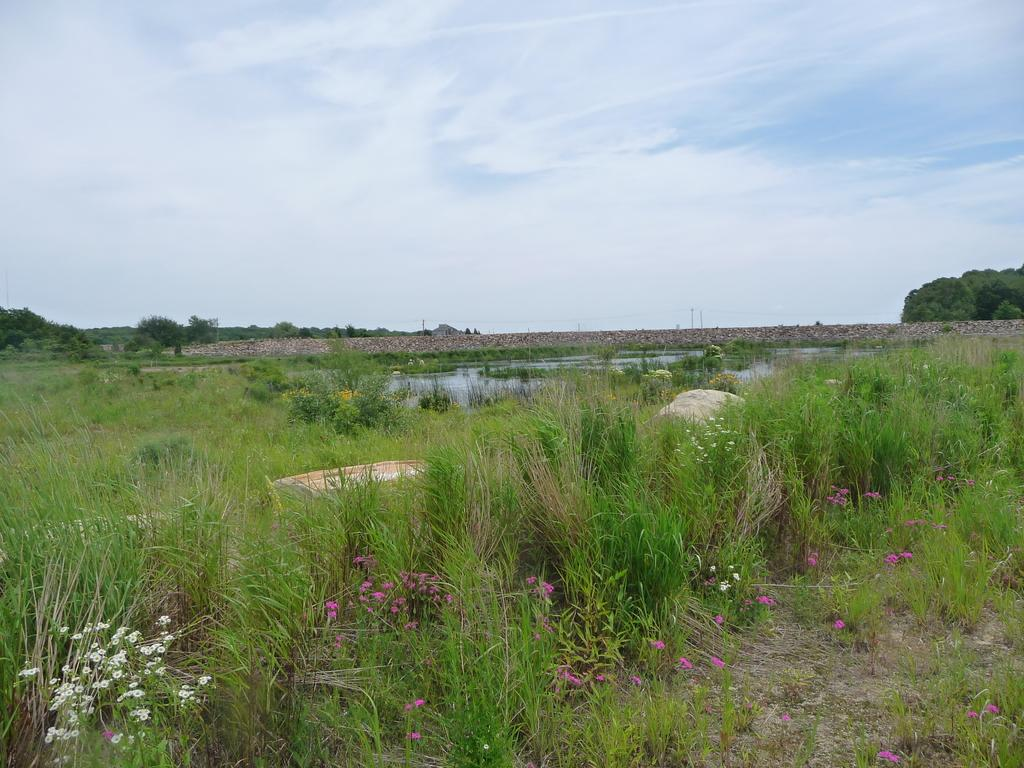What colors are the flowers in the grassland? The flowers in the grassland are purple and white. What can be seen in the background of the image? There is a small water pond, stones, and trees visible in the background. What type of stamp can be seen on the thought in the image? There is no stamp or thought present in the image; it features flowers in a grassland with a background of a water pond, stones, and trees. 